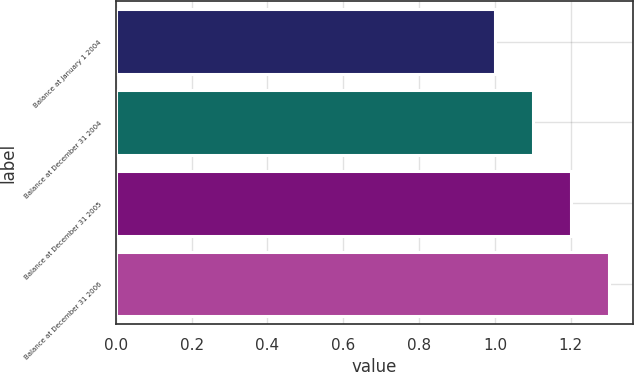Convert chart to OTSL. <chart><loc_0><loc_0><loc_500><loc_500><bar_chart><fcel>Balance at January 1 2004<fcel>Balance at December 31 2004<fcel>Balance at December 31 2005<fcel>Balance at December 31 2006<nl><fcel>1<fcel>1.1<fcel>1.2<fcel>1.3<nl></chart> 